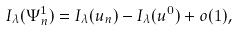Convert formula to latex. <formula><loc_0><loc_0><loc_500><loc_500>I _ { \lambda } ( \Psi _ { n } ^ { 1 } ) = I _ { \lambda } ( u _ { n } ) - I _ { \lambda } ( u ^ { 0 } ) + o ( 1 ) ,</formula> 